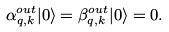Convert formula to latex. <formula><loc_0><loc_0><loc_500><loc_500>\alpha ^ { o u t } _ { { q } , { k } } | 0 \rangle = \beta ^ { o u t } _ { { q } , { k } } | 0 \rangle = 0 .</formula> 